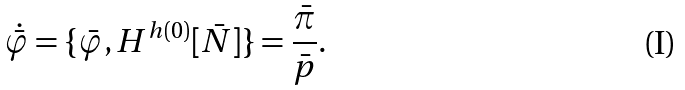<formula> <loc_0><loc_0><loc_500><loc_500>\dot { \bar { \varphi } } = \{ \bar { \varphi } , H ^ { h ( 0 ) } [ \bar { N } ] \} = \frac { \bar { \pi } } { \bar { p } } .</formula> 